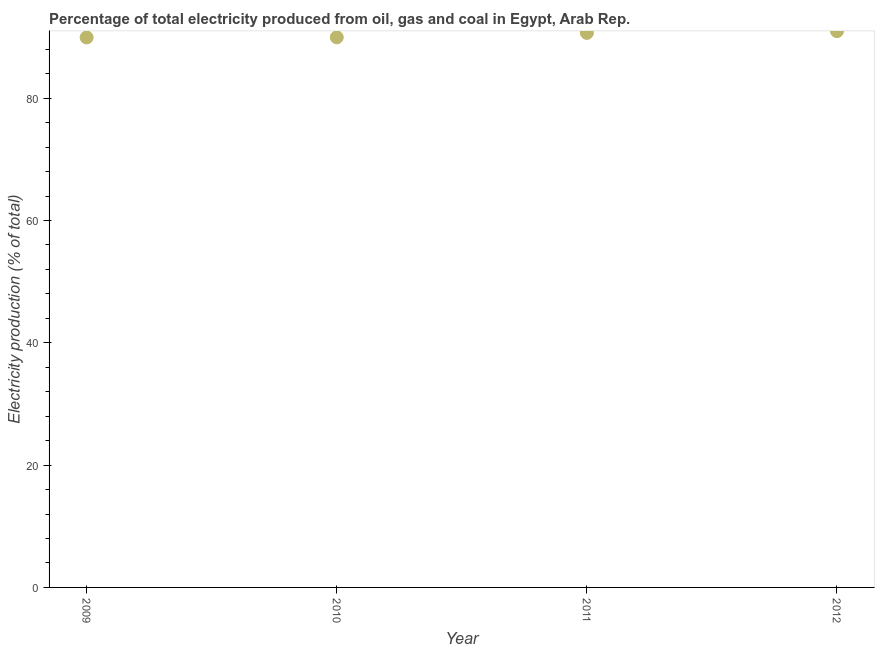What is the electricity production in 2011?
Your answer should be very brief. 90.67. Across all years, what is the maximum electricity production?
Your answer should be very brief. 90.96. Across all years, what is the minimum electricity production?
Your response must be concise. 89.93. In which year was the electricity production maximum?
Your response must be concise. 2012. What is the sum of the electricity production?
Give a very brief answer. 361.52. What is the difference between the electricity production in 2009 and 2012?
Offer a very short reply. -1.03. What is the average electricity production per year?
Offer a terse response. 90.38. What is the median electricity production?
Ensure brevity in your answer.  90.31. In how many years, is the electricity production greater than 16 %?
Ensure brevity in your answer.  4. Do a majority of the years between 2011 and 2010 (inclusive) have electricity production greater than 44 %?
Provide a short and direct response. No. What is the ratio of the electricity production in 2011 to that in 2012?
Your answer should be very brief. 1. Is the electricity production in 2010 less than that in 2011?
Your answer should be very brief. Yes. What is the difference between the highest and the second highest electricity production?
Offer a very short reply. 0.29. Is the sum of the electricity production in 2010 and 2011 greater than the maximum electricity production across all years?
Your answer should be very brief. Yes. What is the difference between the highest and the lowest electricity production?
Offer a terse response. 1.03. Does the electricity production monotonically increase over the years?
Give a very brief answer. Yes. How many years are there in the graph?
Offer a terse response. 4. What is the difference between two consecutive major ticks on the Y-axis?
Give a very brief answer. 20. What is the title of the graph?
Your answer should be compact. Percentage of total electricity produced from oil, gas and coal in Egypt, Arab Rep. What is the label or title of the X-axis?
Ensure brevity in your answer.  Year. What is the label or title of the Y-axis?
Make the answer very short. Electricity production (% of total). What is the Electricity production (% of total) in 2009?
Make the answer very short. 89.93. What is the Electricity production (% of total) in 2010?
Provide a succinct answer. 89.95. What is the Electricity production (% of total) in 2011?
Offer a terse response. 90.67. What is the Electricity production (% of total) in 2012?
Offer a very short reply. 90.96. What is the difference between the Electricity production (% of total) in 2009 and 2010?
Offer a very short reply. -0.02. What is the difference between the Electricity production (% of total) in 2009 and 2011?
Give a very brief answer. -0.74. What is the difference between the Electricity production (% of total) in 2009 and 2012?
Provide a short and direct response. -1.03. What is the difference between the Electricity production (% of total) in 2010 and 2011?
Make the answer very short. -0.72. What is the difference between the Electricity production (% of total) in 2010 and 2012?
Offer a very short reply. -1.01. What is the difference between the Electricity production (% of total) in 2011 and 2012?
Your answer should be compact. -0.29. What is the ratio of the Electricity production (% of total) in 2009 to that in 2011?
Keep it short and to the point. 0.99. What is the ratio of the Electricity production (% of total) in 2010 to that in 2012?
Keep it short and to the point. 0.99. What is the ratio of the Electricity production (% of total) in 2011 to that in 2012?
Offer a very short reply. 1. 